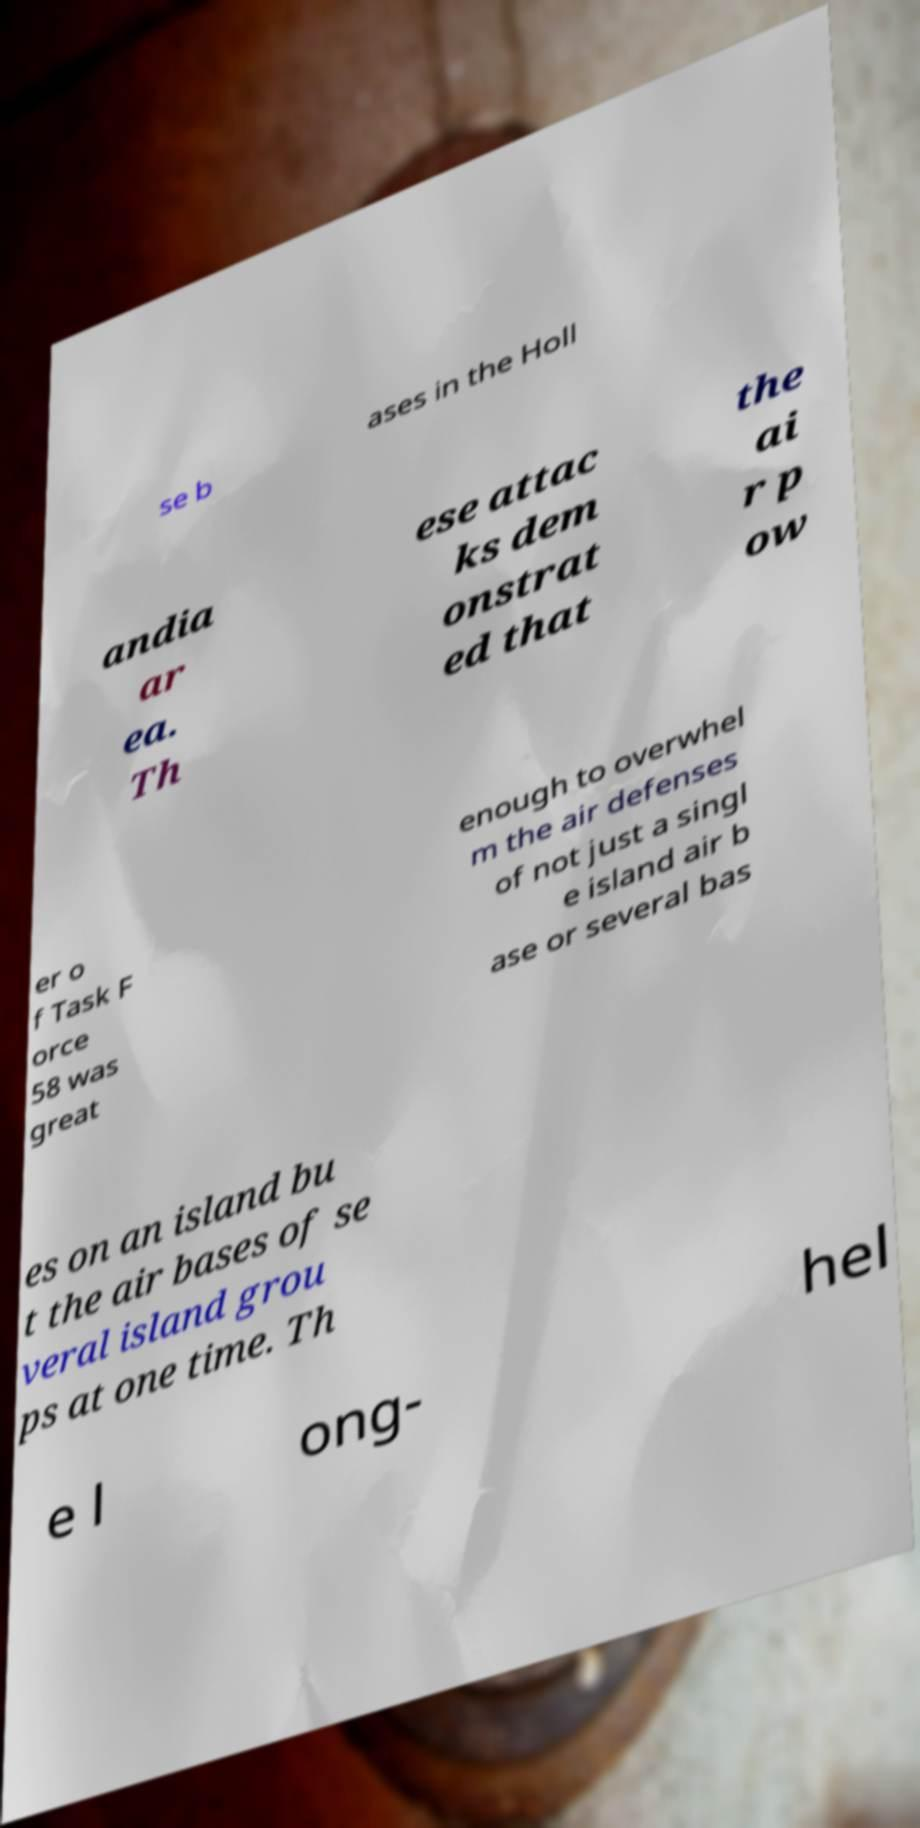I need the written content from this picture converted into text. Can you do that? se b ases in the Holl andia ar ea. Th ese attac ks dem onstrat ed that the ai r p ow er o f Task F orce 58 was great enough to overwhel m the air defenses of not just a singl e island air b ase or several bas es on an island bu t the air bases of se veral island grou ps at one time. Th e l ong- hel 